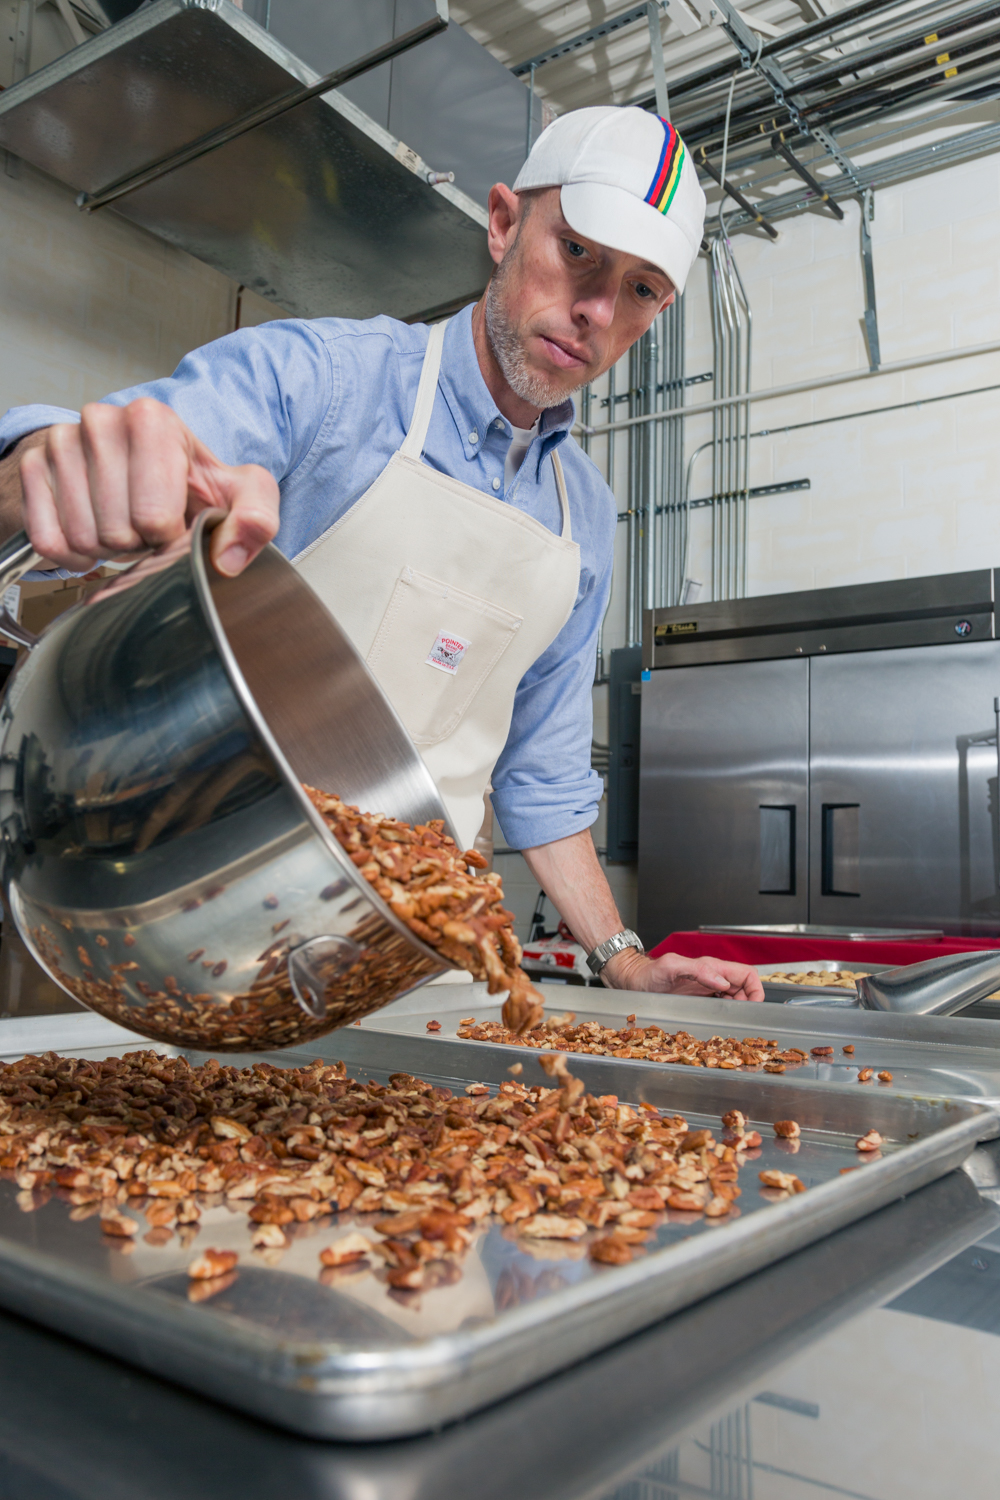Imagine this kitchen is part of a culinary school. What kind of lessons or courses might be taking place here? If this kitchen is part of a culinary school, it could be used for teaching various courses such as advanced baking techniques, large-scale food production, or specialized classes in confectionery arts. Students might be learning how to handle commercial-grade equipment, manage bulk ingredients, and adhere to professional hygiene standards. This would involve both theoretical lessons on food science and practical, hands-on training sessions where students practice their skills in a professional environment. What might be a typical assignment or project for a student in such a course? A typical assignment for a student in such a course might involve creating a batch of gourmet roasted nuts, following a specific recipe to ensure consistency and quality. This project would require the student to measure and prepare the ingredients accurately, use the commercial roasting equipment properly, and package the final product in a professional manner. Additionally, the student might need to document the entire process, noting any challenges faced and how they were overcome, to demonstrate a thorough understanding of large-scale food production. 